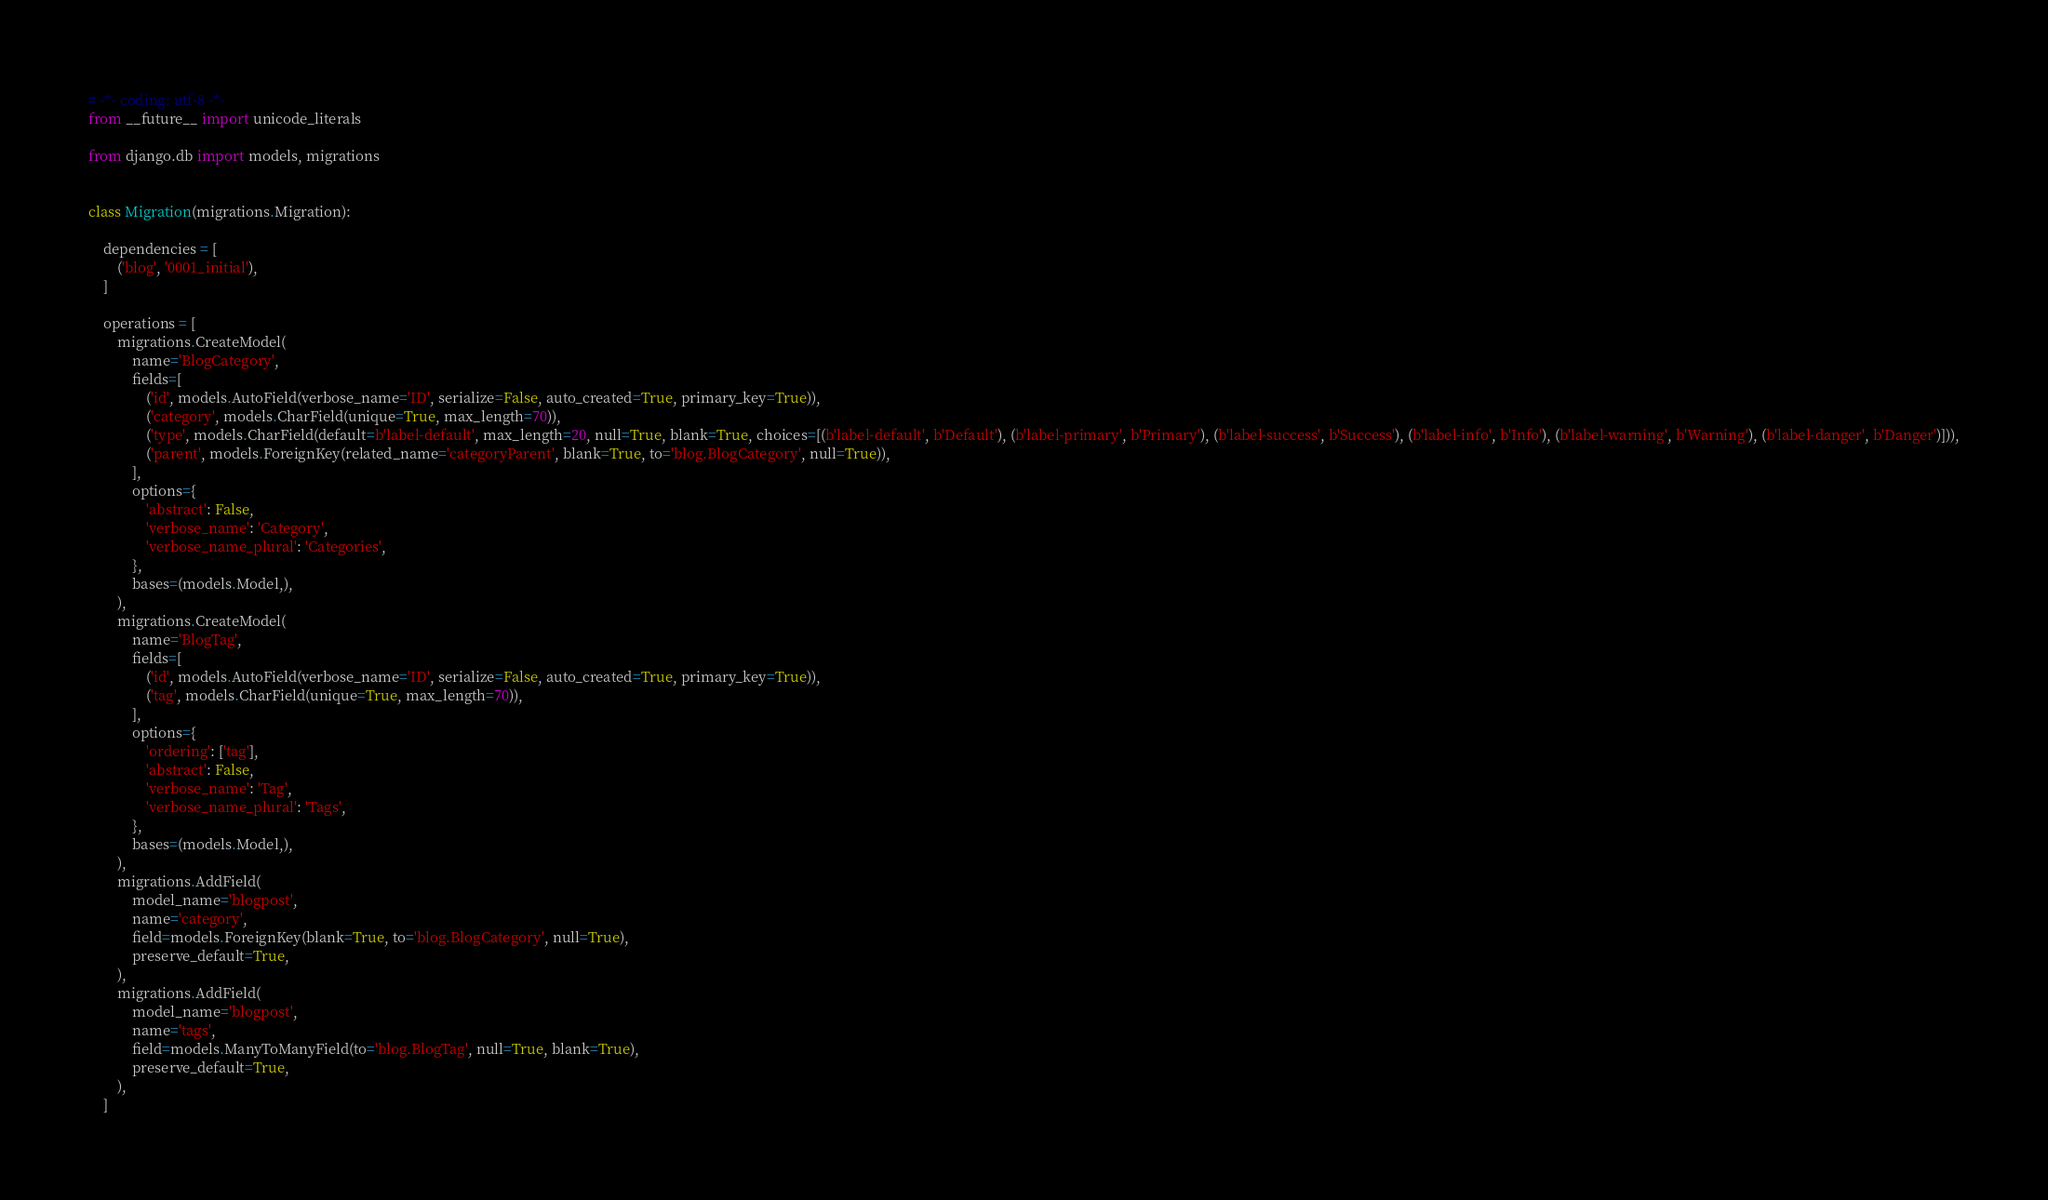Convert code to text. <code><loc_0><loc_0><loc_500><loc_500><_Python_># -*- coding: utf-8 -*-
from __future__ import unicode_literals

from django.db import models, migrations


class Migration(migrations.Migration):

    dependencies = [
        ('blog', '0001_initial'),
    ]

    operations = [
        migrations.CreateModel(
            name='BlogCategory',
            fields=[
                ('id', models.AutoField(verbose_name='ID', serialize=False, auto_created=True, primary_key=True)),
                ('category', models.CharField(unique=True, max_length=70)),
                ('type', models.CharField(default=b'label-default', max_length=20, null=True, blank=True, choices=[(b'label-default', b'Default'), (b'label-primary', b'Primary'), (b'label-success', b'Success'), (b'label-info', b'Info'), (b'label-warning', b'Warning'), (b'label-danger', b'Danger')])),
                ('parent', models.ForeignKey(related_name='categoryParent', blank=True, to='blog.BlogCategory', null=True)),
            ],
            options={
                'abstract': False,
                'verbose_name': 'Category',
                'verbose_name_plural': 'Categories',
            },
            bases=(models.Model,),
        ),
        migrations.CreateModel(
            name='BlogTag',
            fields=[
                ('id', models.AutoField(verbose_name='ID', serialize=False, auto_created=True, primary_key=True)),
                ('tag', models.CharField(unique=True, max_length=70)),
            ],
            options={
                'ordering': ['tag'],
                'abstract': False,
                'verbose_name': 'Tag',
                'verbose_name_plural': 'Tags',
            },
            bases=(models.Model,),
        ),
        migrations.AddField(
            model_name='blogpost',
            name='category',
            field=models.ForeignKey(blank=True, to='blog.BlogCategory', null=True),
            preserve_default=True,
        ),
        migrations.AddField(
            model_name='blogpost',
            name='tags',
            field=models.ManyToManyField(to='blog.BlogTag', null=True, blank=True),
            preserve_default=True,
        ),
    ]
</code> 